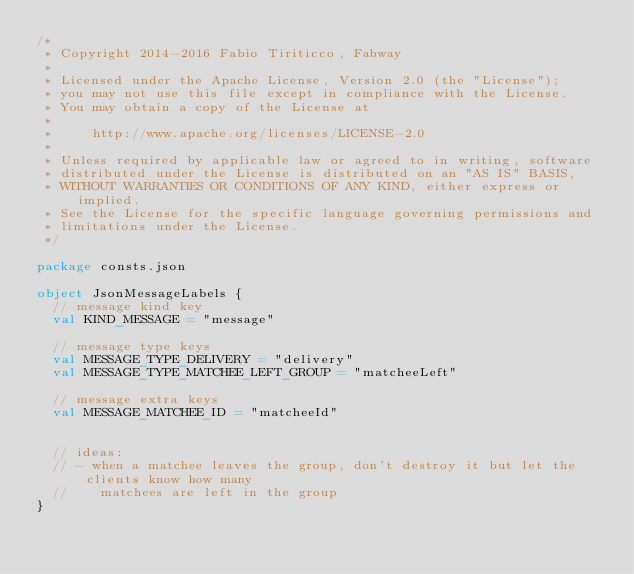Convert code to text. <code><loc_0><loc_0><loc_500><loc_500><_Scala_>/*
 * Copyright 2014-2016 Fabio Tiriticco, Fabway
 *
 * Licensed under the Apache License, Version 2.0 (the "License");
 * you may not use this file except in compliance with the License.
 * You may obtain a copy of the License at
 *
 *     http://www.apache.org/licenses/LICENSE-2.0
 *
 * Unless required by applicable law or agreed to in writing, software
 * distributed under the License is distributed on an "AS IS" BASIS,
 * WITHOUT WARRANTIES OR CONDITIONS OF ANY KIND, either express or implied.
 * See the License for the specific language governing permissions and
 * limitations under the License.
 */

package consts.json

object JsonMessageLabels {
  // message kind key
  val KIND_MESSAGE = "message"

  // message type keys
  val MESSAGE_TYPE_DELIVERY = "delivery"
  val MESSAGE_TYPE_MATCHEE_LEFT_GROUP = "matcheeLeft"

  // message extra keys
  val MESSAGE_MATCHEE_ID = "matcheeId"


  // ideas:
  // - when a matchee leaves the group, don't destroy it but let the clients know how many
  //    matchees are left in the group
}
</code> 